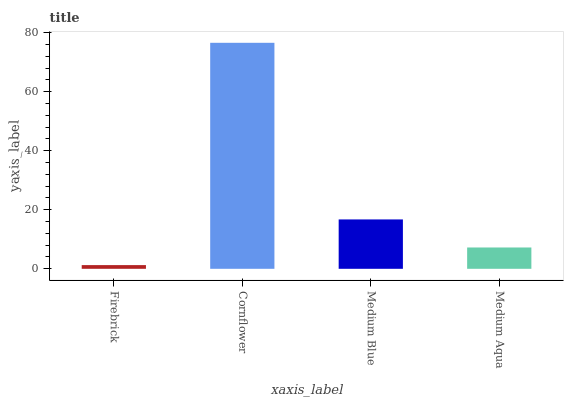Is Firebrick the minimum?
Answer yes or no. Yes. Is Cornflower the maximum?
Answer yes or no. Yes. Is Medium Blue the minimum?
Answer yes or no. No. Is Medium Blue the maximum?
Answer yes or no. No. Is Cornflower greater than Medium Blue?
Answer yes or no. Yes. Is Medium Blue less than Cornflower?
Answer yes or no. Yes. Is Medium Blue greater than Cornflower?
Answer yes or no. No. Is Cornflower less than Medium Blue?
Answer yes or no. No. Is Medium Blue the high median?
Answer yes or no. Yes. Is Medium Aqua the low median?
Answer yes or no. Yes. Is Cornflower the high median?
Answer yes or no. No. Is Cornflower the low median?
Answer yes or no. No. 